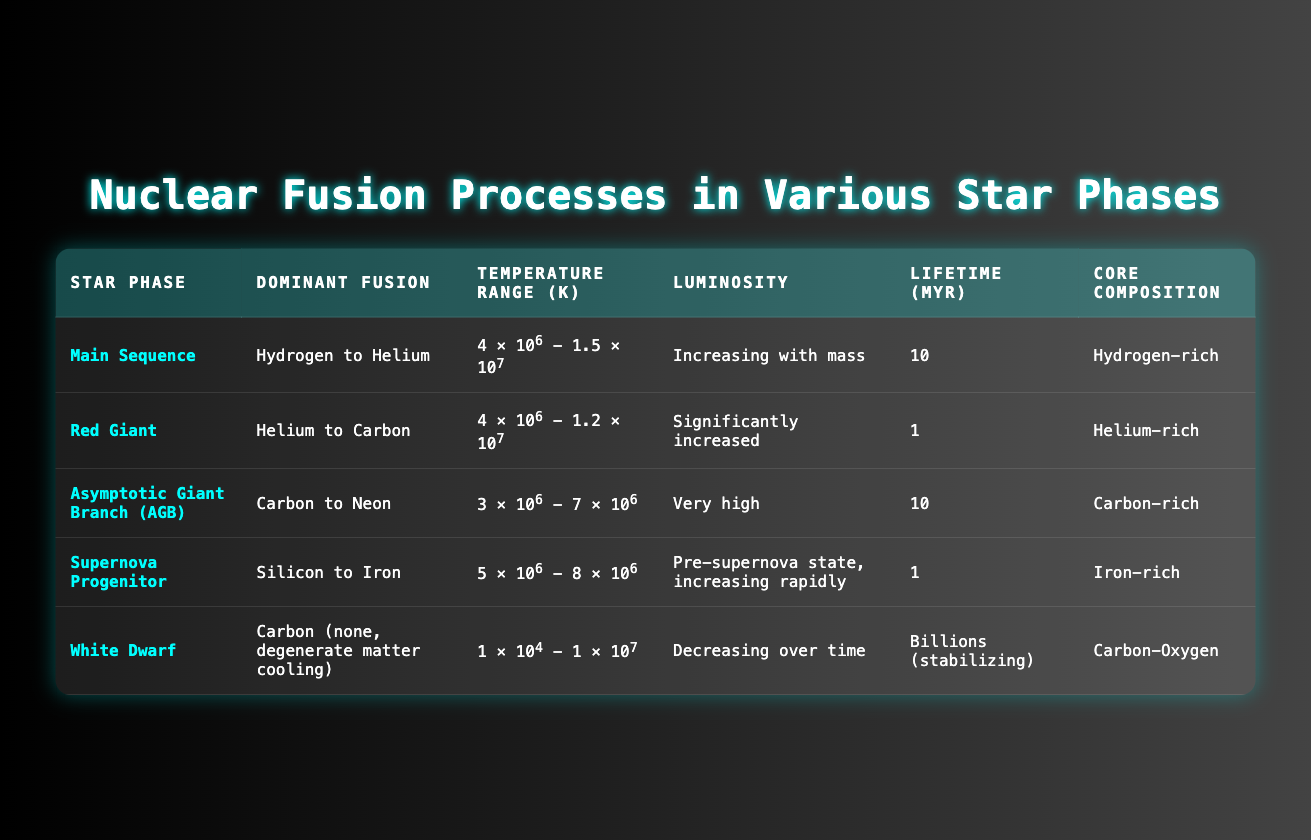What is the dominant fusion process during the Red Giant phase? According to the table, the dominant fusion during the Red Giant phase is "Helium to Carbon."
Answer: Helium to Carbon What is the lifetime of a star in the Asymptotic Giant Branch (AGB) phase? The table shows the lifetime of a star in the AGB phase is 10 million years.
Answer: 10 million years Which star phase has the highest luminosity? The Asymptotic Giant Branch (AGB) phase is described in the table as having "Very high" luminosity, which refers to the highest compared to other phases.
Answer: Very high Is the temperature range in the Supernova Progenitor phase higher than that in the Red Giant phase? The Supernova Progenitor phase has a temperature range of 5 × 10⁶ to 8 × 10⁶ K, while the Red Giant phase has a range of 4 × 10⁶ to 1.2 × 10⁷ K; since the maximum of the Supernova Progenitor phase (8 × 10⁶ K) is lower than the maximum of the Red Giant (1.2 × 10⁷ K), the Supernova Progenitor phase is not higher.
Answer: No What is the average temperature range for the Main Sequence and Red Giant phases? The Main Sequence has a range of 4 × 10⁶ to 1.5 × 10⁷ K, and the Red Giant has a range of 4 × 10⁶ to 1.2 × 10⁷ K. The average of these ranges can be calculated as follows: Main Sequence average is (4 × 10⁶ + 1.5 × 10⁷) / 2 = 9.5 × 10⁶ K, and for Red Giant, it is (4 × 10⁶ + 1.2 × 10⁷) / 2 = 8 × 10⁶ K. Thus, the average of these averages is (9.5 × 10⁶ + 8 × 10⁶) / 2 = 8.75 × 10⁶ K.
Answer: 8.75 × 10⁶ K Which star phase has a core composition that is Iron-rich? The Supernova Progenitor phase is indicated in the table to have an Iron-rich core composition.
Answer: Supernova Progenitor What is the total lifetime of a star in the Main Sequence and White Dwarf phases combined? The Main Sequence phase has a lifetime of 10 million years, and the White Dwarf phase has billions of years for stabilization. Since billions can't easily be quantified in the same scale as millions, we denote it as a vast amount which makes the sum effectively uncountable in millions, but if approximated to just note major lifetime phases: it would approximate to count as significant in the billions.
Answer: Billions (not quantifiable with millions) Is the core composition of a White Dwarf primarily Hydrogen-rich? The table specifies that the core composition of a White Dwarf is Carbon-Oxygen, so it is not Hydrogen-rich.
Answer: No Which phase experiences an increasing luminosity with mass? The table states that the Main Sequence phase experiences an increasing luminosity with mass.
Answer: Main Sequence 